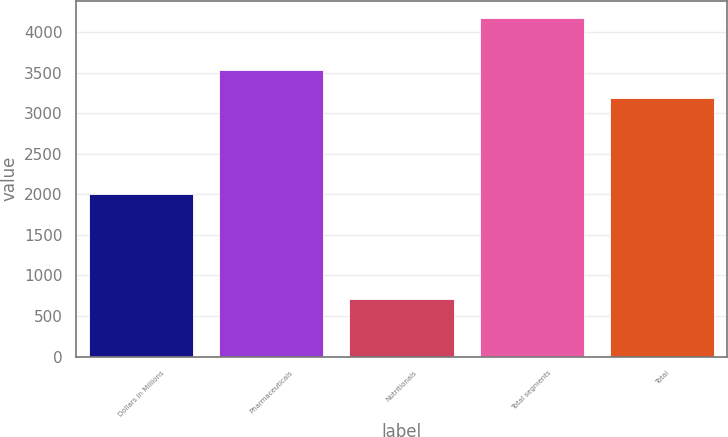Convert chart. <chart><loc_0><loc_0><loc_500><loc_500><bar_chart><fcel>Dollars in Millions<fcel>Pharmaceuticals<fcel>Nutritionals<fcel>Total segments<fcel>Total<nl><fcel>2007<fcel>3533.1<fcel>708<fcel>4179<fcel>3186<nl></chart> 